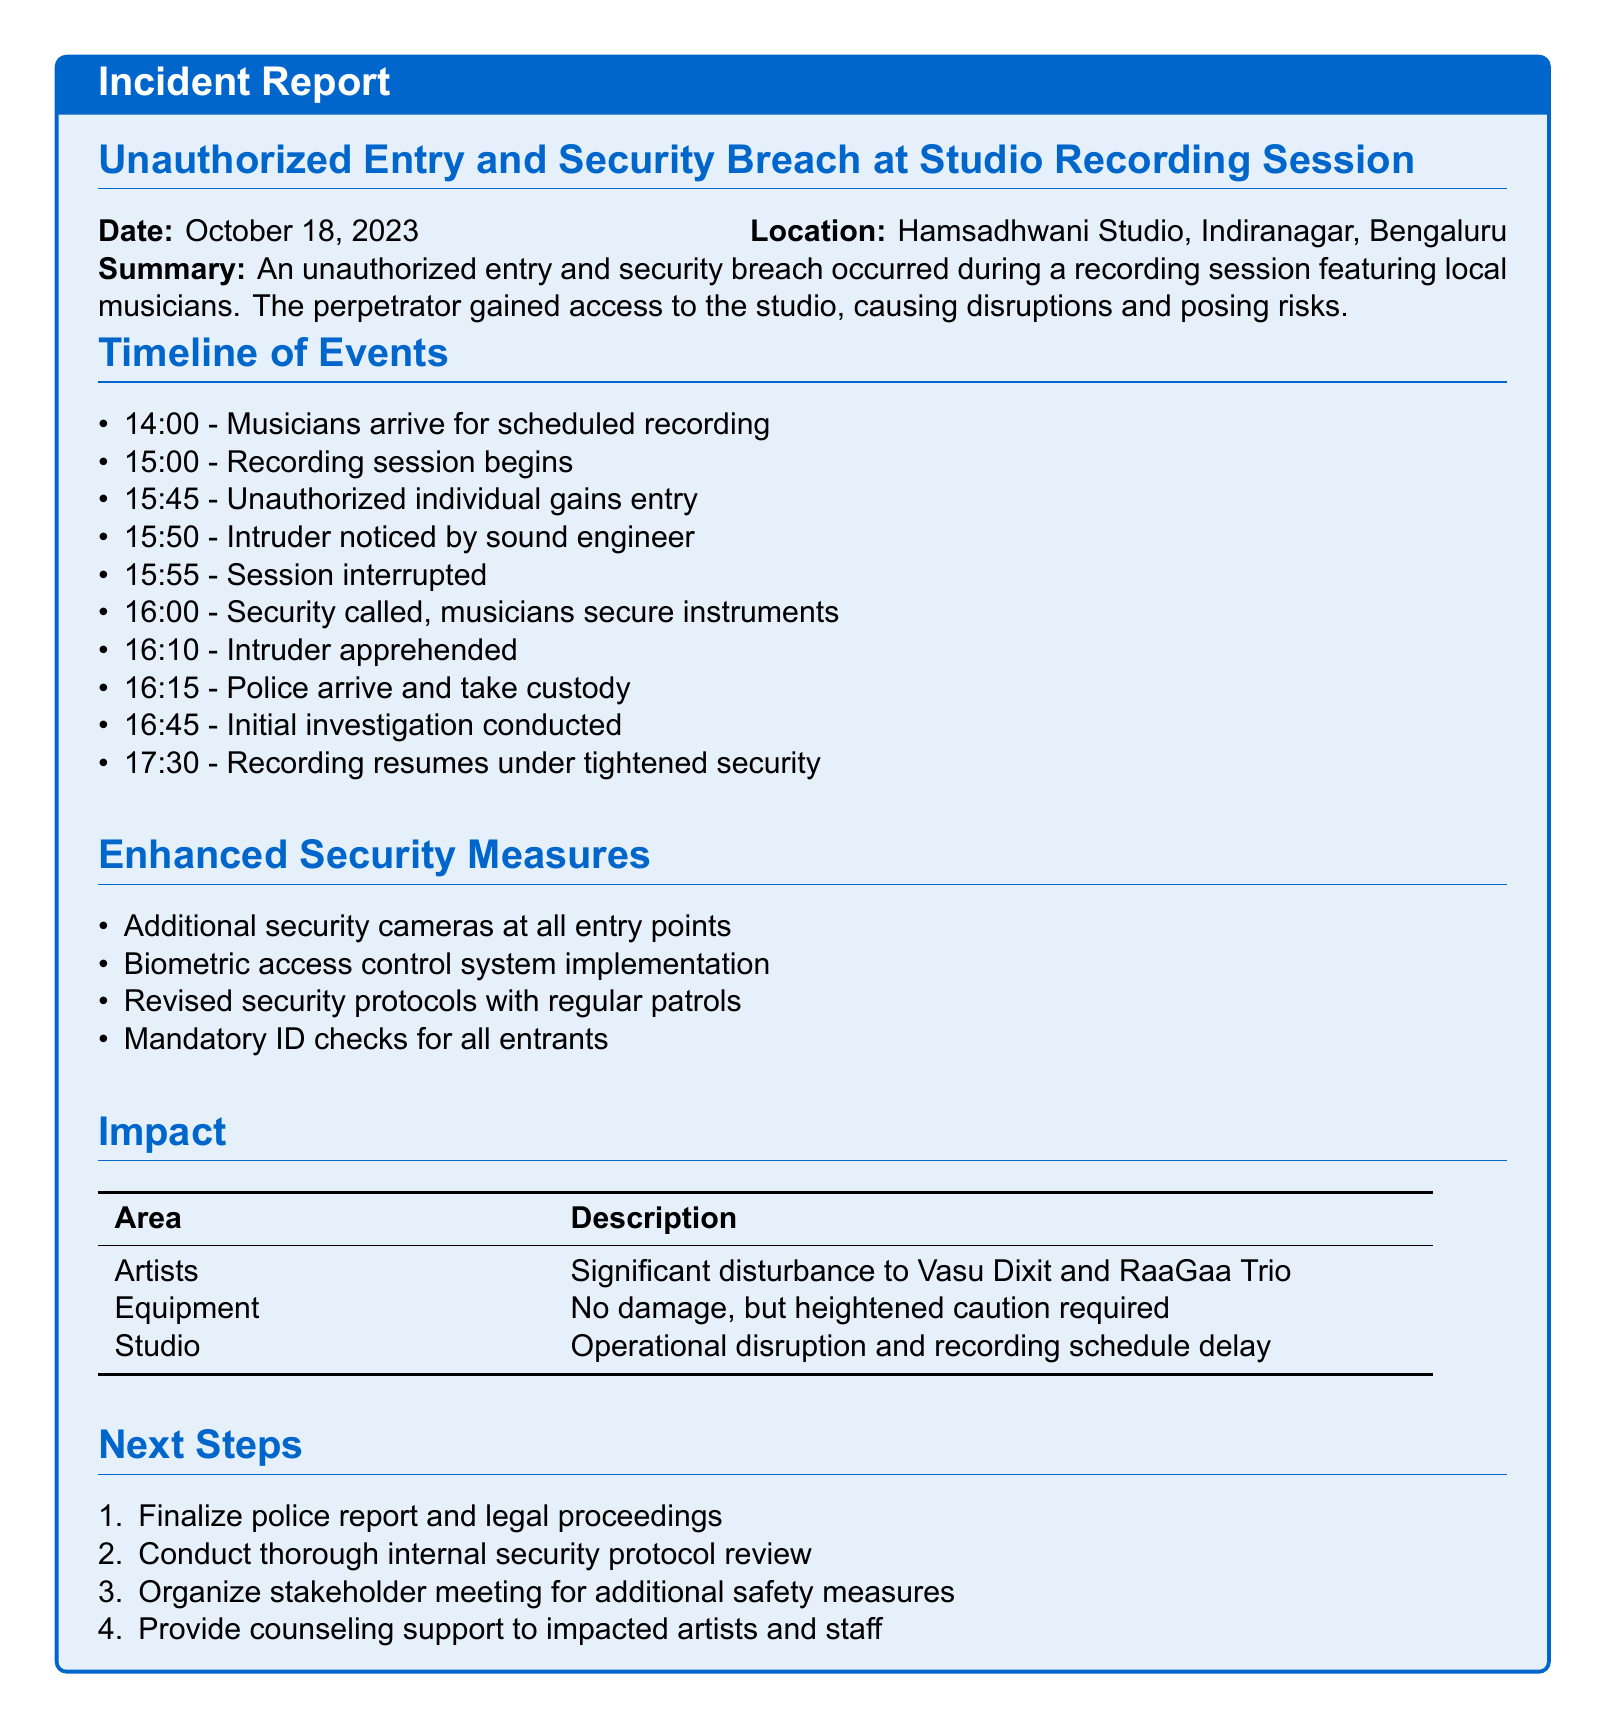what is the date of the incident? The date of the incident is explicitly stated in the report.
Answer: October 18, 2023 where did the incident occur? The location of the incident is mentioned in the document.
Answer: Hamsadhwani Studio, Indiranagar, Bengaluru who were the local musicians involved? The artists involved in the session are listed in the impact section.
Answer: Vasu Dixit and RaaGaa Trio what time did the unauthorized individual gain entry? The specific time of the unauthorized entry is noted in the timeline of events.
Answer: 15:45 what immediate action was taken after the intruder was noticed? The document specifies the action taken promptly after the intruder was noticed.
Answer: Session interrupted how long was the recording session disrupted? The timeline shows the events leading to the resumption of the recording session.
Answer: 1 hour what security measures are being implemented post-incident? The document outlines the enhanced security measures being implemented.
Answer: Additional security cameras at all entry points what was the impact on the studio? The impact section details the effect on studio operations.
Answer: Operational disruption and recording schedule delay what is the next step regarding the police report? The next steps include finalizing the police report and legal proceedings.
Answer: Finalize police report and legal proceedings 